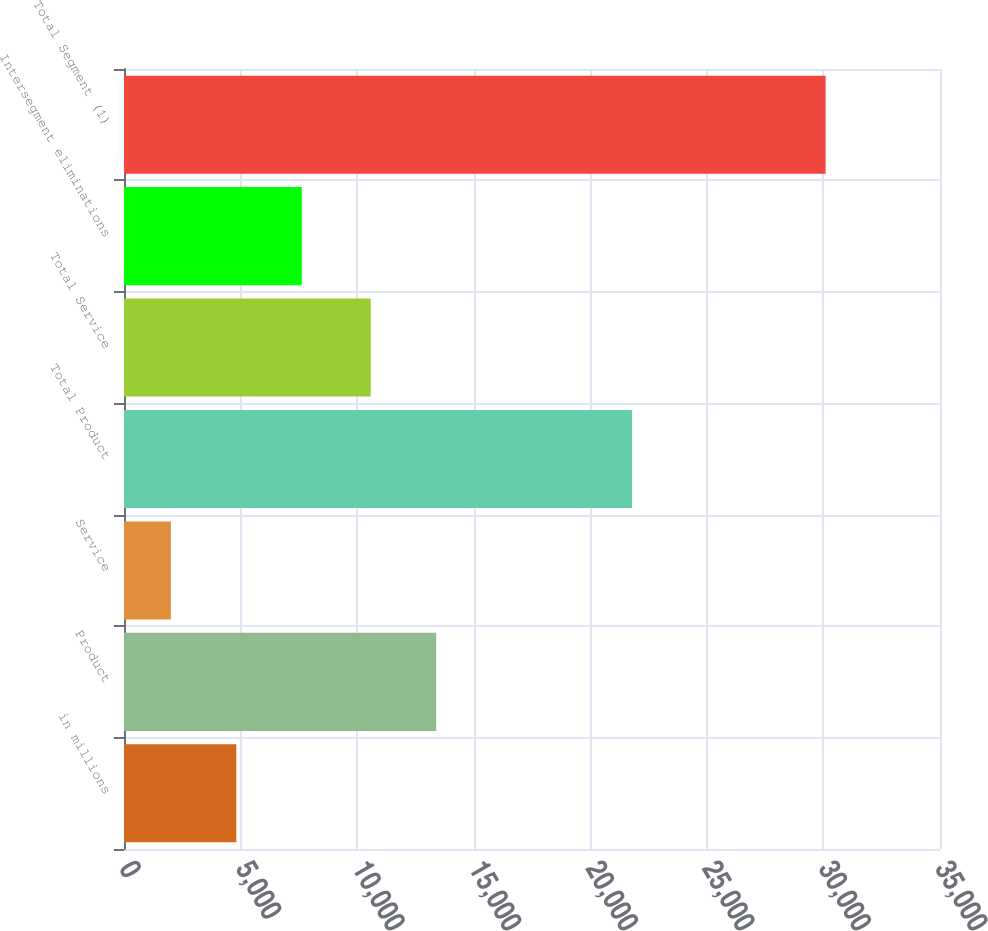<chart> <loc_0><loc_0><loc_500><loc_500><bar_chart><fcel>in millions<fcel>Product<fcel>Service<fcel>Total Product<fcel>Total Service<fcel>Intersegment eliminations<fcel>Total Segment (1)<nl><fcel>4817.6<fcel>13391.6<fcel>2009<fcel>21795<fcel>10583<fcel>7626.2<fcel>30095<nl></chart> 